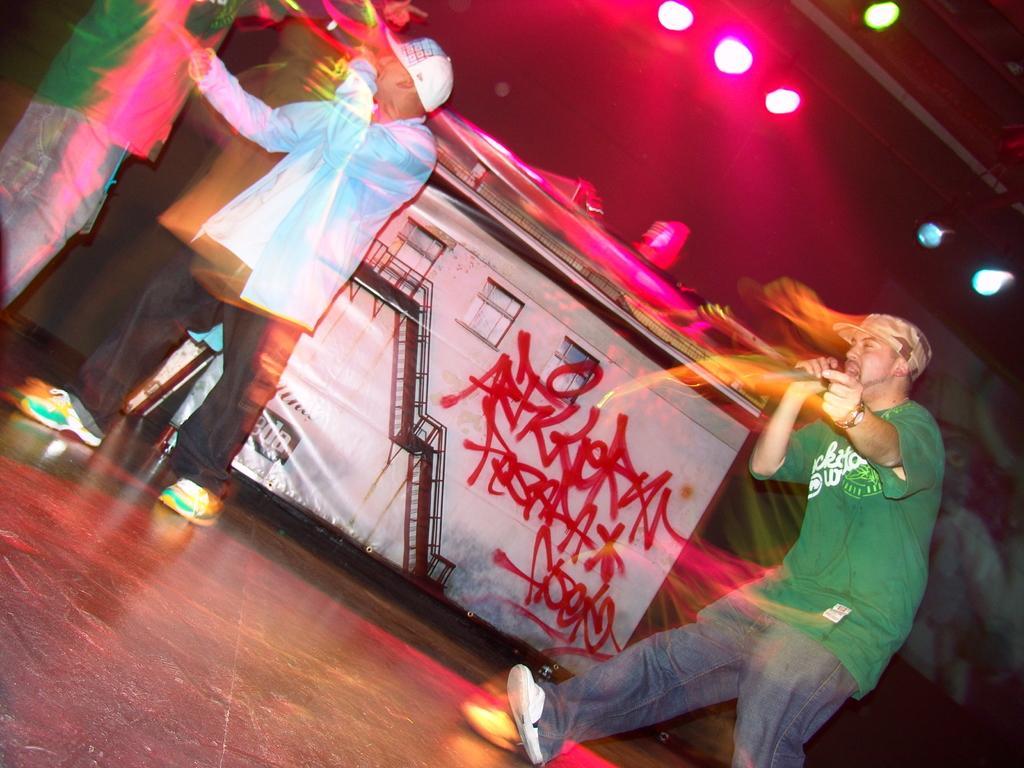In one or two sentences, can you explain what this image depicts? On the right side a man is walking and singing in the microphone. He wore a green color t-shirt, in the middle there are lights. 